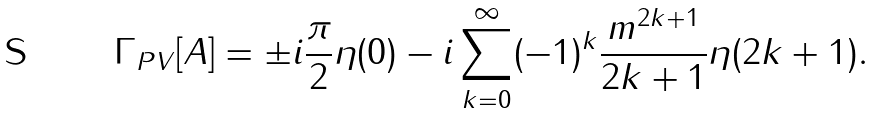Convert formula to latex. <formula><loc_0><loc_0><loc_500><loc_500>\Gamma _ { P V } [ A ] = \pm i \frac { \pi } { 2 } \eta ( 0 ) - i \sum _ { k = 0 } ^ { \infty } ( - 1 ) ^ { k } \frac { m ^ { 2 k + 1 } } { 2 k + 1 } \eta ( 2 k + 1 ) .</formula> 